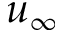Convert formula to latex. <formula><loc_0><loc_0><loc_500><loc_500>u _ { \infty }</formula> 